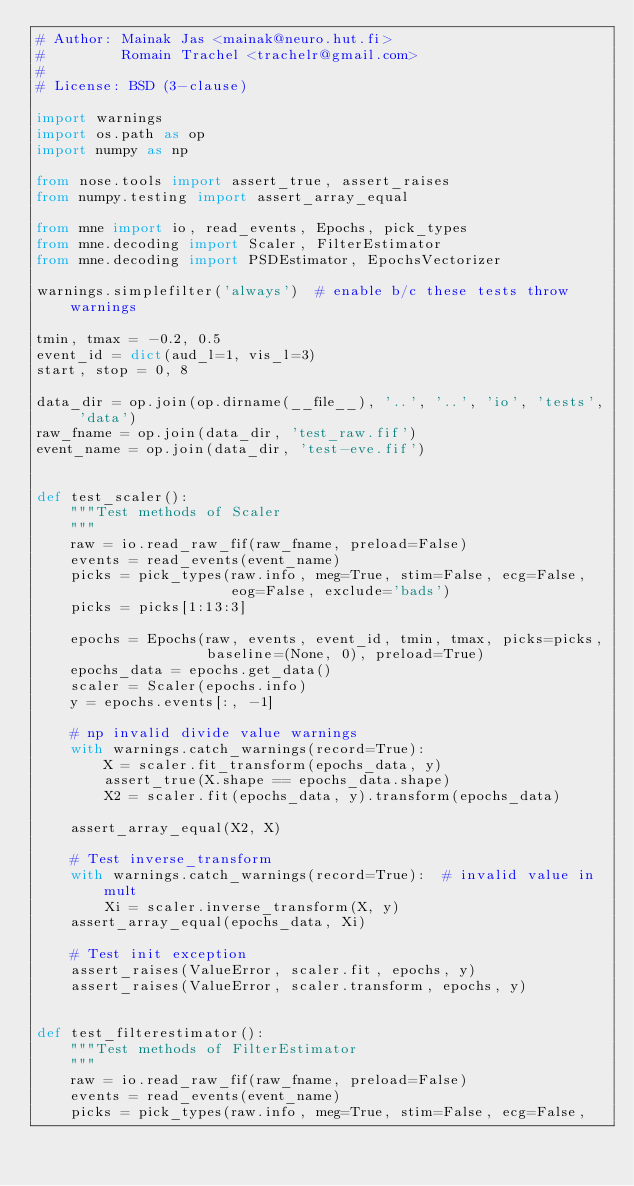Convert code to text. <code><loc_0><loc_0><loc_500><loc_500><_Python_># Author: Mainak Jas <mainak@neuro.hut.fi>
#         Romain Trachel <trachelr@gmail.com>
#
# License: BSD (3-clause)

import warnings
import os.path as op
import numpy as np

from nose.tools import assert_true, assert_raises
from numpy.testing import assert_array_equal

from mne import io, read_events, Epochs, pick_types
from mne.decoding import Scaler, FilterEstimator
from mne.decoding import PSDEstimator, EpochsVectorizer

warnings.simplefilter('always')  # enable b/c these tests throw warnings

tmin, tmax = -0.2, 0.5
event_id = dict(aud_l=1, vis_l=3)
start, stop = 0, 8

data_dir = op.join(op.dirname(__file__), '..', '..', 'io', 'tests', 'data')
raw_fname = op.join(data_dir, 'test_raw.fif')
event_name = op.join(data_dir, 'test-eve.fif')


def test_scaler():
    """Test methods of Scaler
    """
    raw = io.read_raw_fif(raw_fname, preload=False)
    events = read_events(event_name)
    picks = pick_types(raw.info, meg=True, stim=False, ecg=False,
                       eog=False, exclude='bads')
    picks = picks[1:13:3]

    epochs = Epochs(raw, events, event_id, tmin, tmax, picks=picks,
                    baseline=(None, 0), preload=True)
    epochs_data = epochs.get_data()
    scaler = Scaler(epochs.info)
    y = epochs.events[:, -1]

    # np invalid divide value warnings
    with warnings.catch_warnings(record=True):
        X = scaler.fit_transform(epochs_data, y)
        assert_true(X.shape == epochs_data.shape)
        X2 = scaler.fit(epochs_data, y).transform(epochs_data)

    assert_array_equal(X2, X)

    # Test inverse_transform
    with warnings.catch_warnings(record=True):  # invalid value in mult
        Xi = scaler.inverse_transform(X, y)
    assert_array_equal(epochs_data, Xi)

    # Test init exception
    assert_raises(ValueError, scaler.fit, epochs, y)
    assert_raises(ValueError, scaler.transform, epochs, y)


def test_filterestimator():
    """Test methods of FilterEstimator
    """
    raw = io.read_raw_fif(raw_fname, preload=False)
    events = read_events(event_name)
    picks = pick_types(raw.info, meg=True, stim=False, ecg=False,</code> 